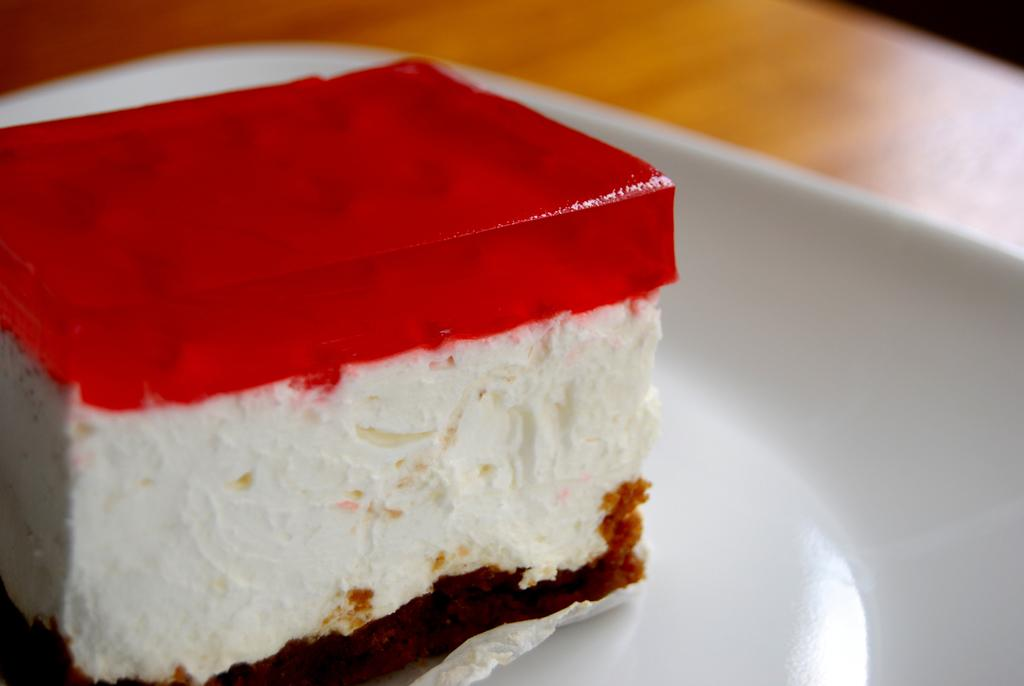What is on the plate in the image? There is a piece of cake on a plate in the image. What might be supporting the plate in the image? The plate appears to be placed on a wooden board. What type of cap is being worn by the cake in the image? There is no cap present on the cake in the image. What scientific theory is being demonstrated by the cake in the image? There is no scientific theory being demonstrated by the cake in the image. 